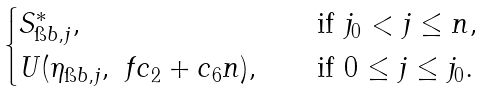Convert formula to latex. <formula><loc_0><loc_0><loc_500><loc_500>\begin{cases} S _ { \i b , j } ^ { \ast } , \ \ & \text { if $j_{0}<j\leq n$} , \\ U ( \eta _ { \i b , j } , \ f { c _ { 2 } + c _ { 6 } } n ) , \ \ & \text { if $0\leq j\leq j_{0}$} . \end{cases}</formula> 